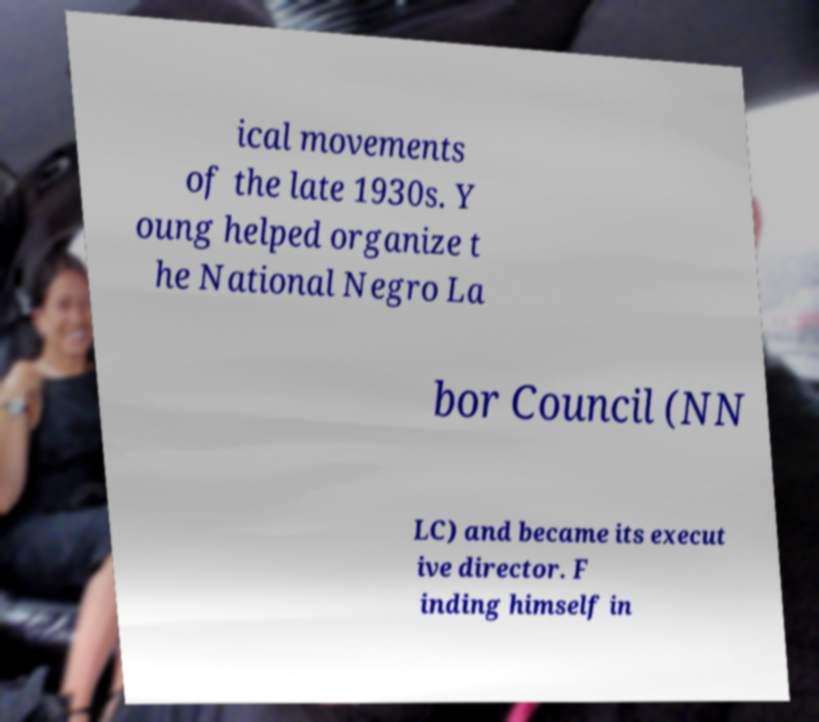There's text embedded in this image that I need extracted. Can you transcribe it verbatim? ical movements of the late 1930s. Y oung helped organize t he National Negro La bor Council (NN LC) and became its execut ive director. F inding himself in 